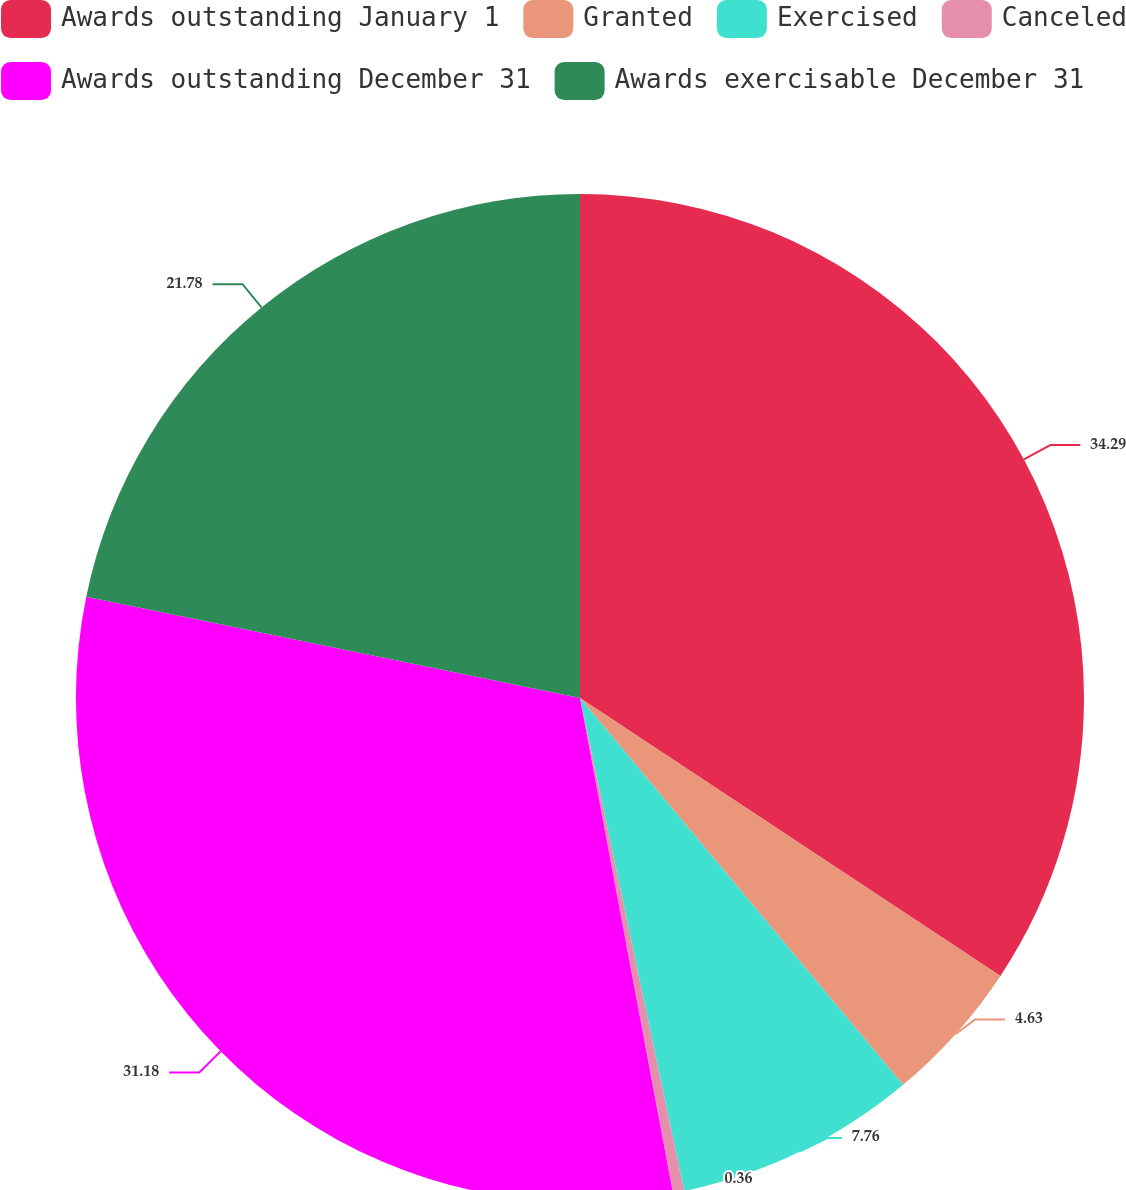<chart> <loc_0><loc_0><loc_500><loc_500><pie_chart><fcel>Awards outstanding January 1<fcel>Granted<fcel>Exercised<fcel>Canceled<fcel>Awards outstanding December 31<fcel>Awards exercisable December 31<nl><fcel>34.3%<fcel>4.63%<fcel>7.76%<fcel>0.36%<fcel>31.18%<fcel>21.78%<nl></chart> 